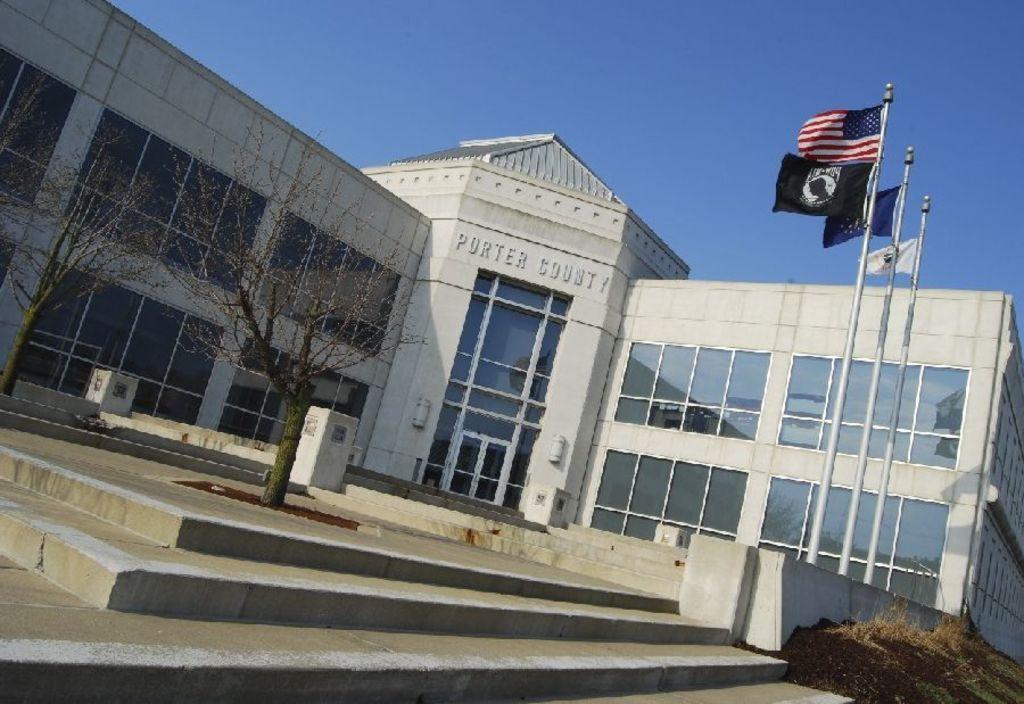How would you summarize this image in a sentence or two? In this image in the background there is a building which is white in colour and there is some text written on the building. In front of the building there are dry trees, there are flags, and there's grass on the ground. 